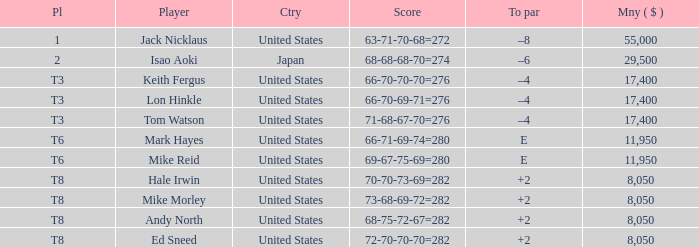What to par is located in the united states and has the player by the name of hale irwin? 2.0. 